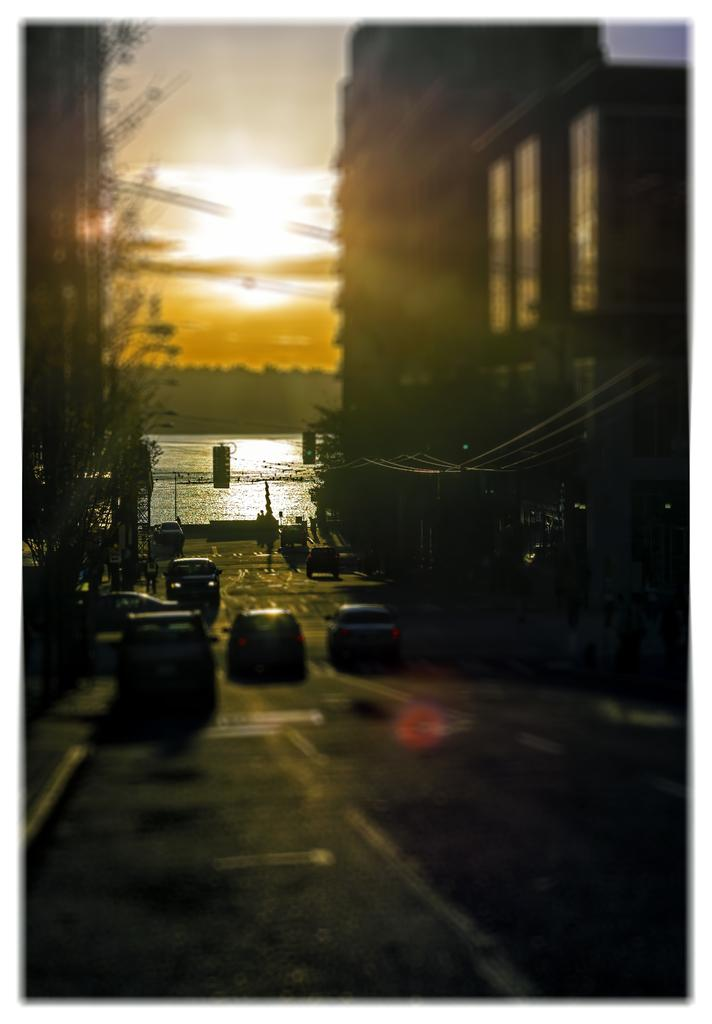What can be seen on the road in the image? There are vehicles on the road in the image. How would you describe the background of the image? The background is blurred, and there is a building, the sky, and a tree visible. Can you see a picture of the sun hanging on the tree in the background? There is no picture of the sun hanging on the tree in the background; the tree and the sun are separate elements in the image. 